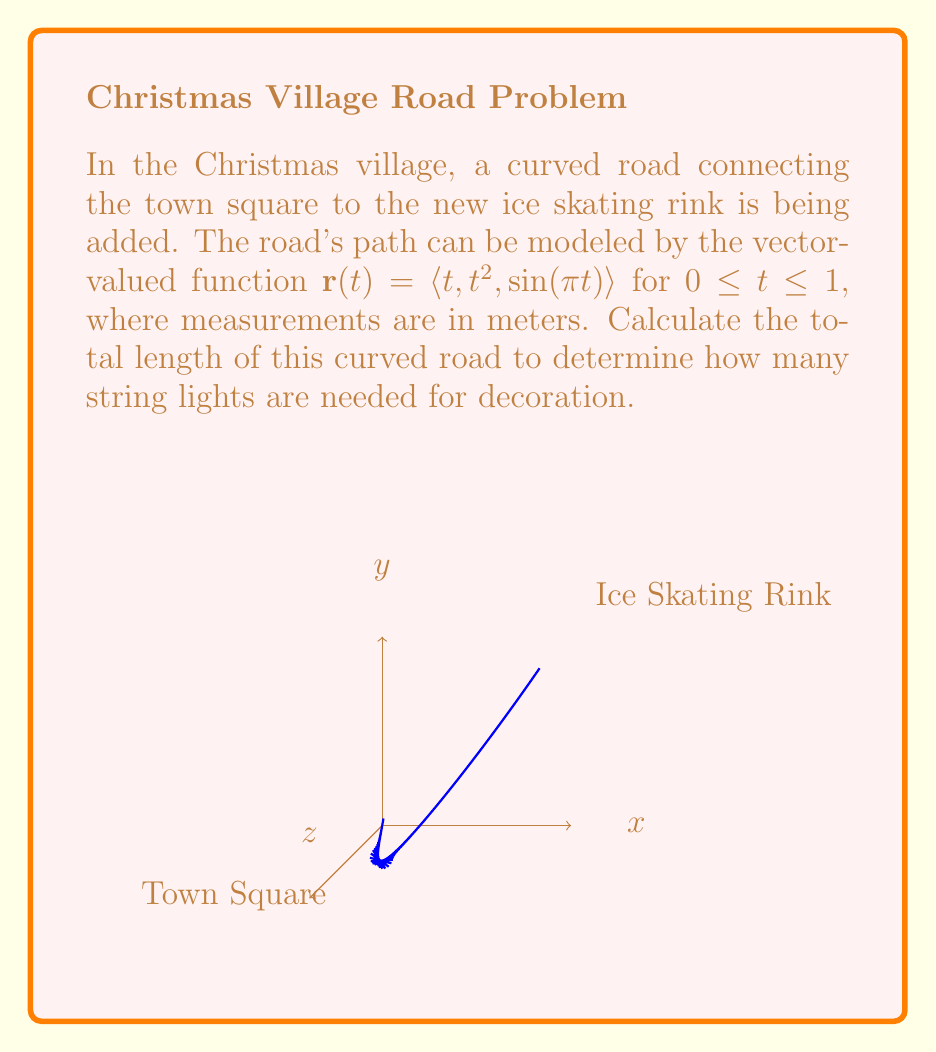Give your solution to this math problem. To find the arc length of the curved road, we need to use the arc length formula for a vector-valued function:

$$ L = \int_a^b |\mathbf{r}'(t)| dt $$

where $\mathbf{r}'(t)$ is the derivative of the vector-valued function.

Step 1: Find $\mathbf{r}'(t)$
$\mathbf{r}(t) = \langle t, t^2, \sin(\pi t) \rangle$
$\mathbf{r}'(t) = \langle 1, 2t, \pi \cos(\pi t) \rangle$

Step 2: Calculate $|\mathbf{r}'(t)|$
$|\mathbf{r}'(t)| = \sqrt{1^2 + (2t)^2 + (\pi \cos(\pi t))^2}$
$= \sqrt{1 + 4t^2 + \pi^2 \cos^2(\pi t)}$

Step 3: Set up the integral
$$ L = \int_0^1 \sqrt{1 + 4t^2 + \pi^2 \cos^2(\pi t)} dt $$

Step 4: This integral cannot be evaluated analytically, so we need to use numerical integration methods. Using a computer algebra system or numerical integration tool, we can approximate the value of this integral.

The result of the numerical integration is approximately 1.6976 meters.
Answer: $1.6976$ meters 